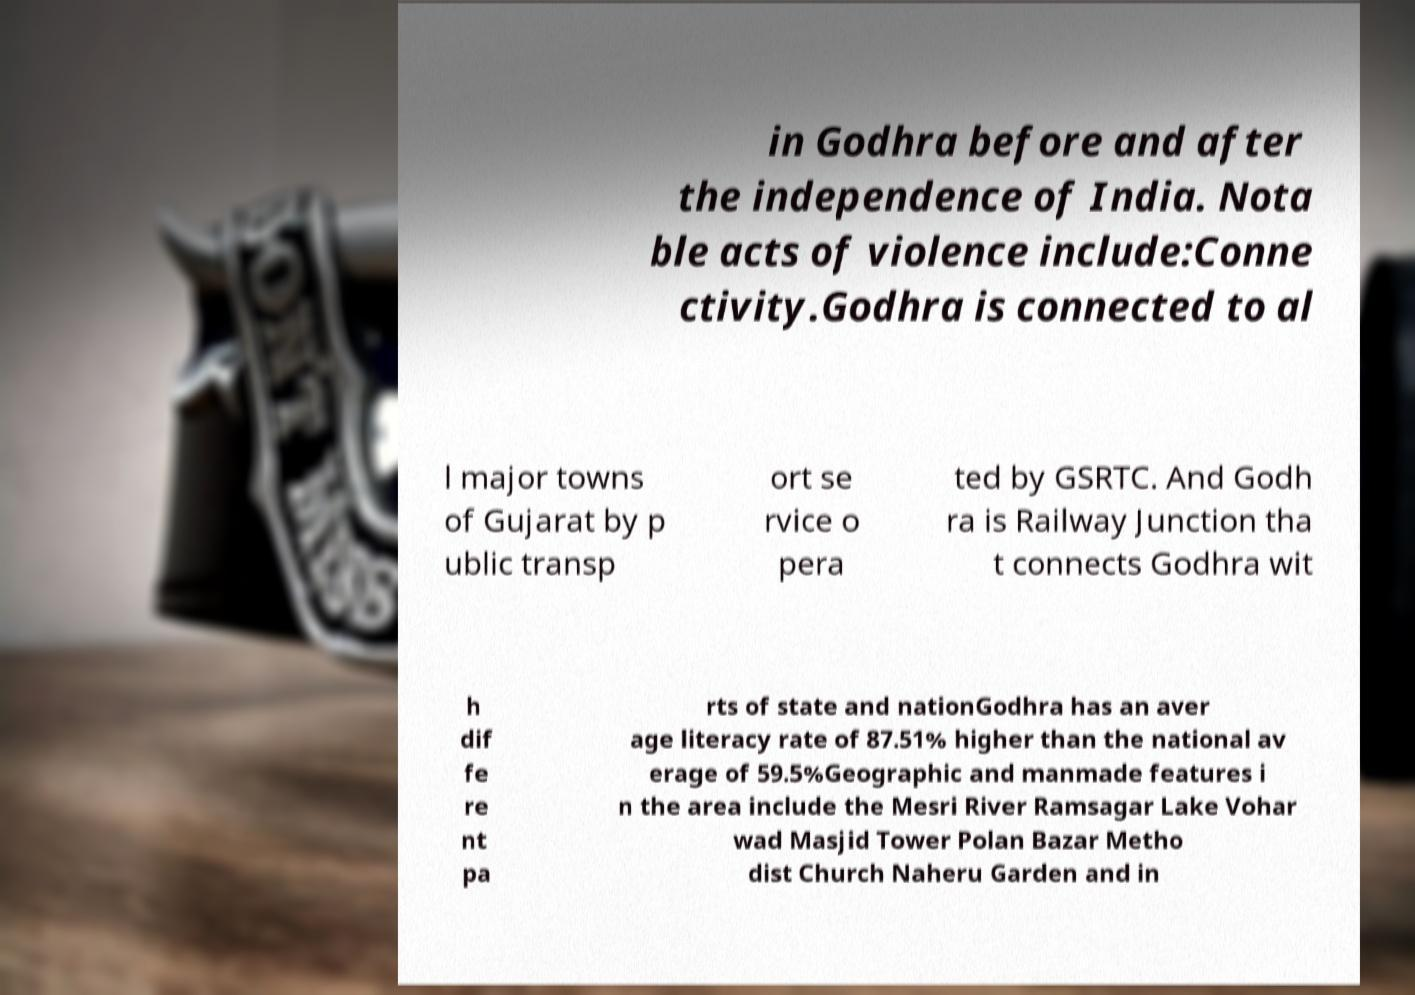For documentation purposes, I need the text within this image transcribed. Could you provide that? in Godhra before and after the independence of India. Nota ble acts of violence include:Conne ctivity.Godhra is connected to al l major towns of Gujarat by p ublic transp ort se rvice o pera ted by GSRTC. And Godh ra is Railway Junction tha t connects Godhra wit h dif fe re nt pa rts of state and nationGodhra has an aver age literacy rate of 87.51% higher than the national av erage of 59.5%Geographic and manmade features i n the area include the Mesri River Ramsagar Lake Vohar wad Masjid Tower Polan Bazar Metho dist Church Naheru Garden and in 